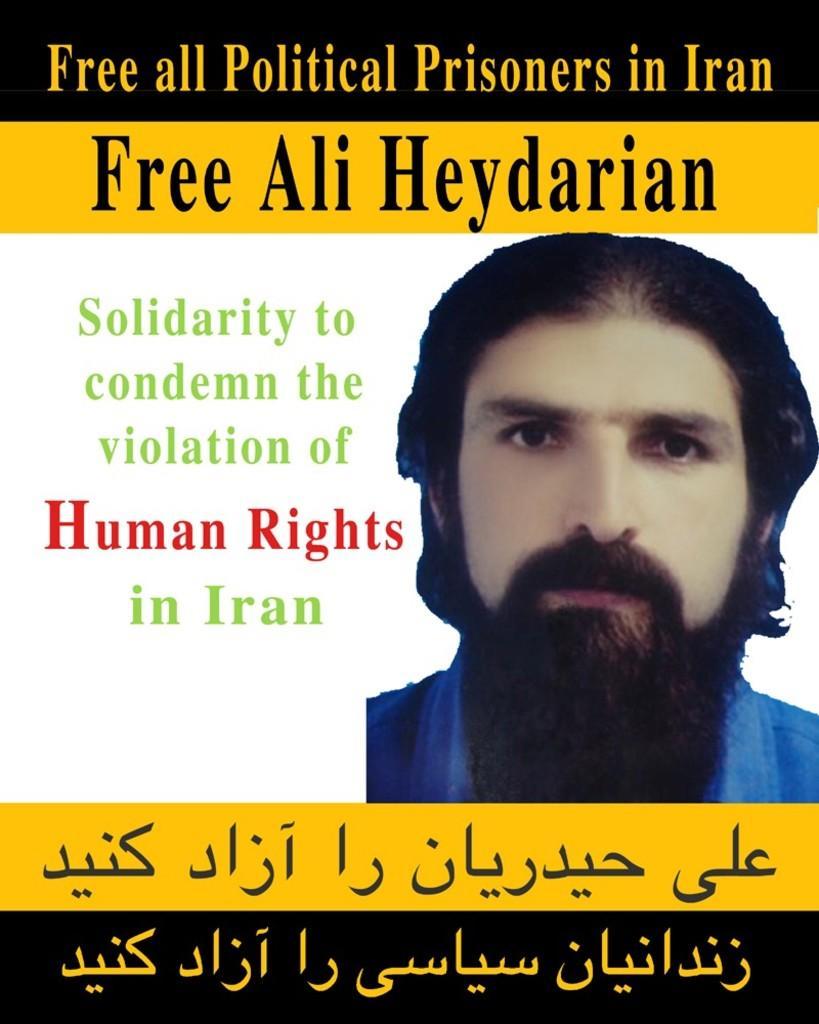Could you give a brief overview of what you see in this image? There is a poster. There is an image of a man at the right. A matter is written. 